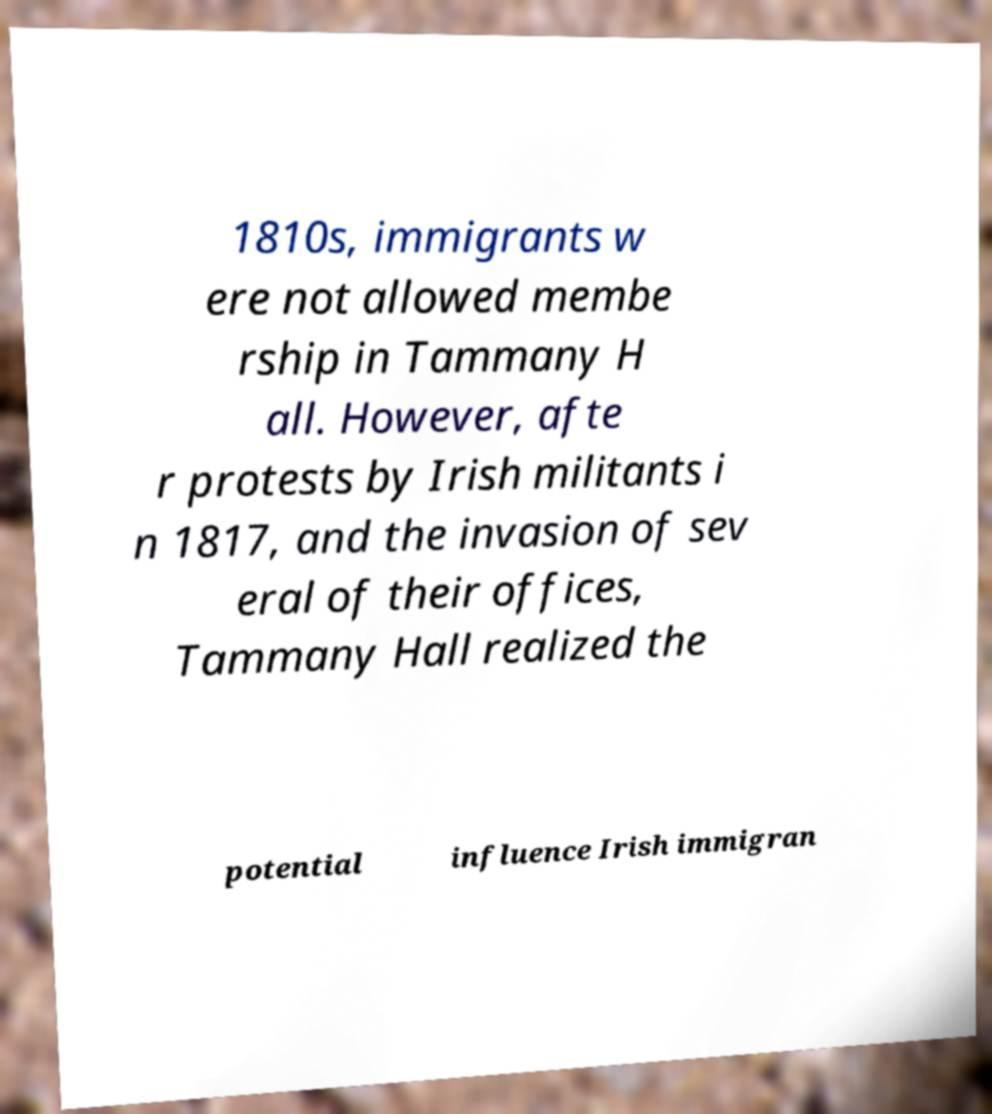Can you read and provide the text displayed in the image?This photo seems to have some interesting text. Can you extract and type it out for me? 1810s, immigrants w ere not allowed membe rship in Tammany H all. However, afte r protests by Irish militants i n 1817, and the invasion of sev eral of their offices, Tammany Hall realized the potential influence Irish immigran 